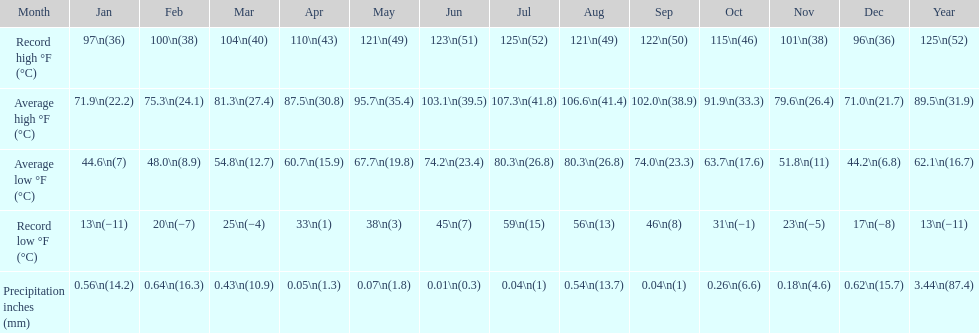What was the duration of the monthly average temperature being 100 degrees or higher? 4 months. Would you mind parsing the complete table? {'header': ['Month', 'Jan', 'Feb', 'Mar', 'Apr', 'May', 'Jun', 'Jul', 'Aug', 'Sep', 'Oct', 'Nov', 'Dec', 'Year'], 'rows': [['Record high °F (°C)', '97\\n(36)', '100\\n(38)', '104\\n(40)', '110\\n(43)', '121\\n(49)', '123\\n(51)', '125\\n(52)', '121\\n(49)', '122\\n(50)', '115\\n(46)', '101\\n(38)', '96\\n(36)', '125\\n(52)'], ['Average high °F (°C)', '71.9\\n(22.2)', '75.3\\n(24.1)', '81.3\\n(27.4)', '87.5\\n(30.8)', '95.7\\n(35.4)', '103.1\\n(39.5)', '107.3\\n(41.8)', '106.6\\n(41.4)', '102.0\\n(38.9)', '91.9\\n(33.3)', '79.6\\n(26.4)', '71.0\\n(21.7)', '89.5\\n(31.9)'], ['Average low °F (°C)', '44.6\\n(7)', '48.0\\n(8.9)', '54.8\\n(12.7)', '60.7\\n(15.9)', '67.7\\n(19.8)', '74.2\\n(23.4)', '80.3\\n(26.8)', '80.3\\n(26.8)', '74.0\\n(23.3)', '63.7\\n(17.6)', '51.8\\n(11)', '44.2\\n(6.8)', '62.1\\n(16.7)'], ['Record low °F (°C)', '13\\n(−11)', '20\\n(−7)', '25\\n(−4)', '33\\n(1)', '38\\n(3)', '45\\n(7)', '59\\n(15)', '56\\n(13)', '46\\n(8)', '31\\n(−1)', '23\\n(−5)', '17\\n(−8)', '13\\n(−11)'], ['Precipitation inches (mm)', '0.56\\n(14.2)', '0.64\\n(16.3)', '0.43\\n(10.9)', '0.05\\n(1.3)', '0.07\\n(1.8)', '0.01\\n(0.3)', '0.04\\n(1)', '0.54\\n(13.7)', '0.04\\n(1)', '0.26\\n(6.6)', '0.18\\n(4.6)', '0.62\\n(15.7)', '3.44\\n(87.4)']]} 